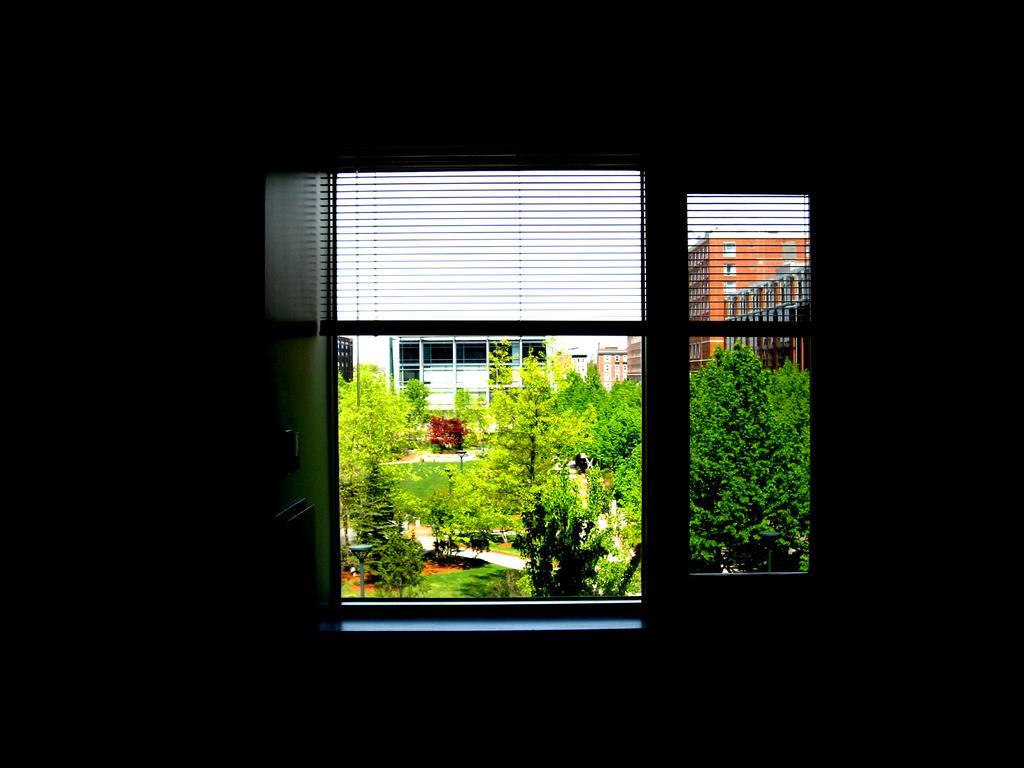In one or two sentences, can you explain what this image depicts? In this image I can see few trees, buildings and windows. In front I can see the window. 